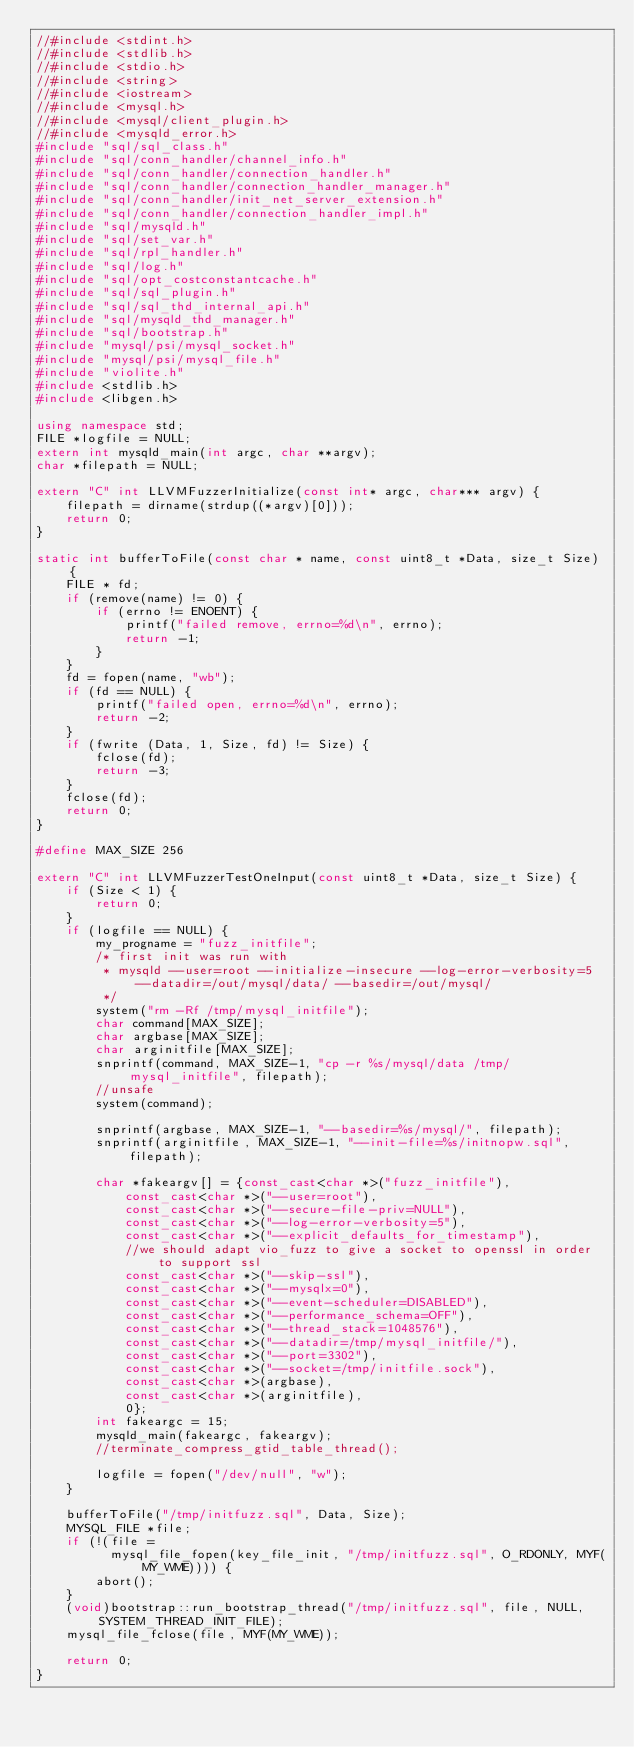<code> <loc_0><loc_0><loc_500><loc_500><_C++_>//#include <stdint.h>
//#include <stdlib.h>
//#include <stdio.h>
//#include <string>
//#include <iostream>
//#include <mysql.h>
//#include <mysql/client_plugin.h>
//#include <mysqld_error.h>
#include "sql/sql_class.h"
#include "sql/conn_handler/channel_info.h"
#include "sql/conn_handler/connection_handler.h"
#include "sql/conn_handler/connection_handler_manager.h"
#include "sql/conn_handler/init_net_server_extension.h"
#include "sql/conn_handler/connection_handler_impl.h"
#include "sql/mysqld.h"
#include "sql/set_var.h"
#include "sql/rpl_handler.h"
#include "sql/log.h"
#include "sql/opt_costconstantcache.h"
#include "sql/sql_plugin.h"
#include "sql/sql_thd_internal_api.h"
#include "sql/mysqld_thd_manager.h"
#include "sql/bootstrap.h"
#include "mysql/psi/mysql_socket.h"
#include "mysql/psi/mysql_file.h"
#include "violite.h"
#include <stdlib.h>
#include <libgen.h>

using namespace std;
FILE *logfile = NULL;
extern int mysqld_main(int argc, char **argv);
char *filepath = NULL;

extern "C" int LLVMFuzzerInitialize(const int* argc, char*** argv) {
    filepath = dirname(strdup((*argv)[0]));
    return 0;
}

static int bufferToFile(const char * name, const uint8_t *Data, size_t Size) {
    FILE * fd;
    if (remove(name) != 0) {
        if (errno != ENOENT) {
            printf("failed remove, errno=%d\n", errno);
            return -1;
        }
    }
    fd = fopen(name, "wb");
    if (fd == NULL) {
        printf("failed open, errno=%d\n", errno);
        return -2;
    }
    if (fwrite (Data, 1, Size, fd) != Size) {
        fclose(fd);
        return -3;
    }
    fclose(fd);
    return 0;
}

#define MAX_SIZE 256

extern "C" int LLVMFuzzerTestOneInput(const uint8_t *Data, size_t Size) {
    if (Size < 1) {
        return 0;
    }
    if (logfile == NULL) {
        my_progname = "fuzz_initfile";
        /* first init was run with
         * mysqld --user=root --initialize-insecure --log-error-verbosity=5 --datadir=/out/mysql/data/ --basedir=/out/mysql/
         */
        system("rm -Rf /tmp/mysql_initfile");
        char command[MAX_SIZE];
        char argbase[MAX_SIZE];
        char arginitfile[MAX_SIZE];
        snprintf(command, MAX_SIZE-1, "cp -r %s/mysql/data /tmp/mysql_initfile", filepath);
        //unsafe
        system(command);

        snprintf(argbase, MAX_SIZE-1, "--basedir=%s/mysql/", filepath);
        snprintf(arginitfile, MAX_SIZE-1, "--init-file=%s/initnopw.sql", filepath);

        char *fakeargv[] = {const_cast<char *>("fuzz_initfile"),
            const_cast<char *>("--user=root"),
            const_cast<char *>("--secure-file-priv=NULL"),
            const_cast<char *>("--log-error-verbosity=5"),
            const_cast<char *>("--explicit_defaults_for_timestamp"),
            //we should adapt vio_fuzz to give a socket to openssl in order to support ssl
            const_cast<char *>("--skip-ssl"),
            const_cast<char *>("--mysqlx=0"),
            const_cast<char *>("--event-scheduler=DISABLED"),
            const_cast<char *>("--performance_schema=OFF"),
            const_cast<char *>("--thread_stack=1048576"),
            const_cast<char *>("--datadir=/tmp/mysql_initfile/"),
            const_cast<char *>("--port=3302"),
            const_cast<char *>("--socket=/tmp/initfile.sock"),
            const_cast<char *>(argbase),
            const_cast<char *>(arginitfile),
            0};
        int fakeargc = 15;
        mysqld_main(fakeargc, fakeargv);
        //terminate_compress_gtid_table_thread();

        logfile = fopen("/dev/null", "w");
    }

    bufferToFile("/tmp/initfuzz.sql", Data, Size);
    MYSQL_FILE *file;
    if (!(file =
          mysql_file_fopen(key_file_init, "/tmp/initfuzz.sql", O_RDONLY, MYF(MY_WME)))) {
        abort();
    }
    (void)bootstrap::run_bootstrap_thread("/tmp/initfuzz.sql", file, NULL, SYSTEM_THREAD_INIT_FILE);
    mysql_file_fclose(file, MYF(MY_WME));

    return 0;
}
</code> 